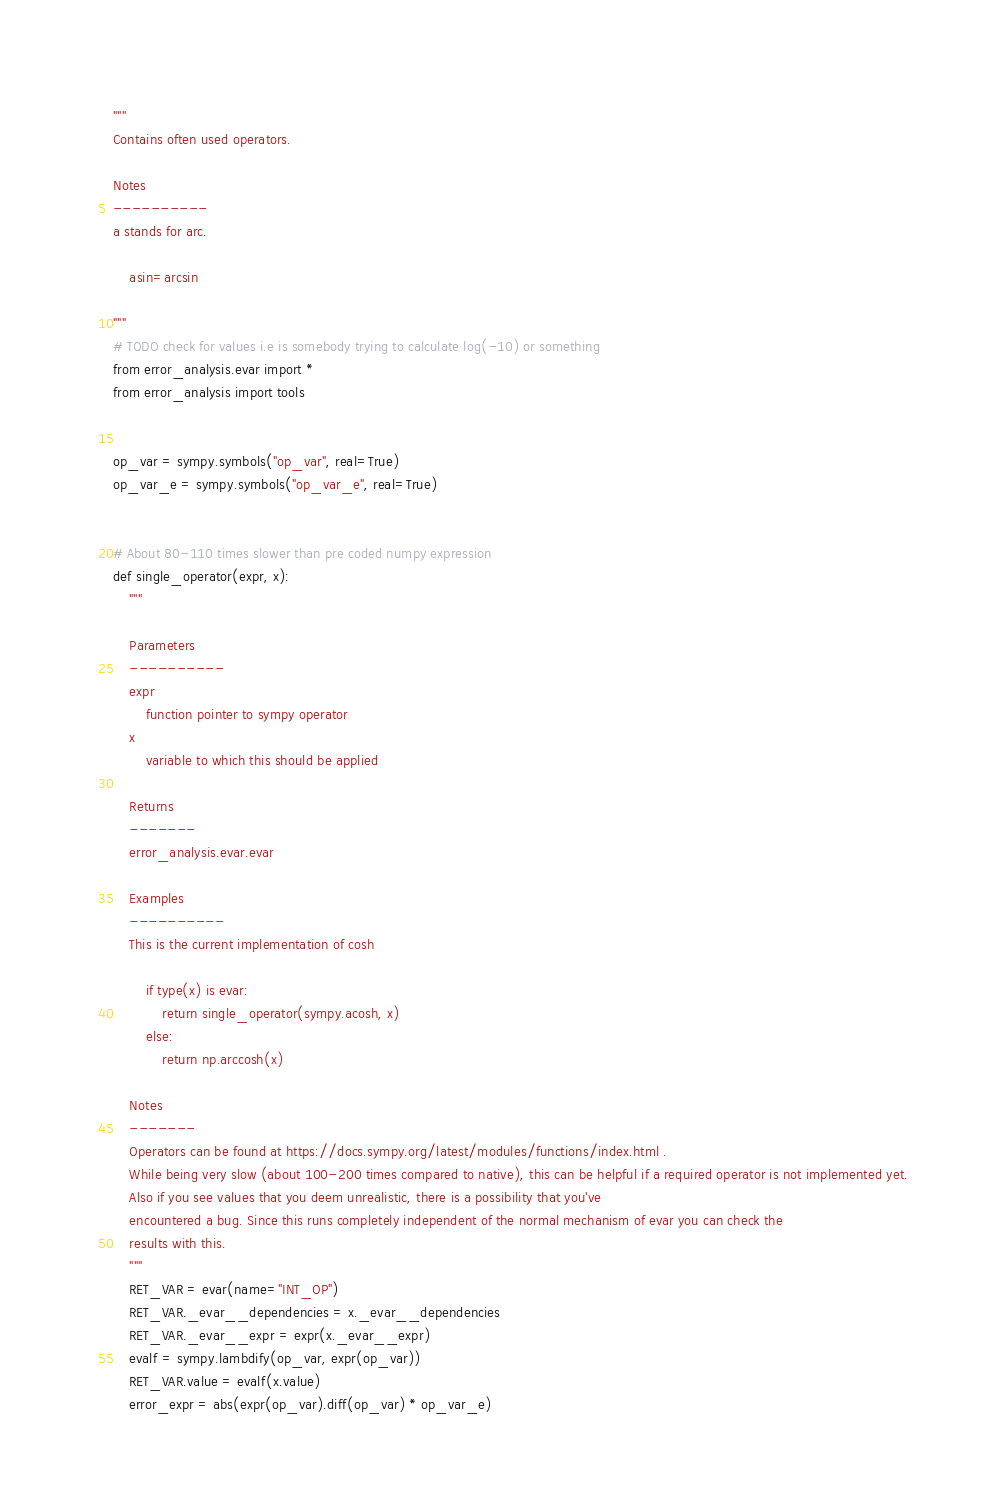Convert code to text. <code><loc_0><loc_0><loc_500><loc_500><_Python_>"""
Contains often used operators.

Notes
----------
a stands for arc.

    asin=arcsin

"""
# TODO check for values i.e is somebody trying to calculate log(-10) or something
from error_analysis.evar import *
from error_analysis import tools


op_var = sympy.symbols("op_var", real=True)
op_var_e = sympy.symbols("op_var_e", real=True)


# About 80-110 times slower than pre coded numpy expression
def single_operator(expr, x):
    """

    Parameters
    ----------
    expr
        function pointer to sympy operator
    x
        variable to which this should be applied

    Returns
    -------
    error_analysis.evar.evar

    Examples
    ----------
    This is the current implementation of cosh

        if type(x) is evar:
            return single_operator(sympy.acosh, x)
        else:
            return np.arccosh(x)

    Notes
    -------
    Operators can be found at https://docs.sympy.org/latest/modules/functions/index.html .
    While being very slow (about 100-200 times compared to native), this can be helpful if a required operator is not implemented yet.
    Also if you see values that you deem unrealistic, there is a possibility that you've
    encountered a bug. Since this runs completely independent of the normal mechanism of evar you can check the
    results with this.
    """
    RET_VAR = evar(name="INT_OP")
    RET_VAR._evar__dependencies = x._evar__dependencies
    RET_VAR._evar__expr = expr(x._evar__expr)
    evalf = sympy.lambdify(op_var, expr(op_var))
    RET_VAR.value = evalf(x.value)
    error_expr = abs(expr(op_var).diff(op_var) * op_var_e)</code> 